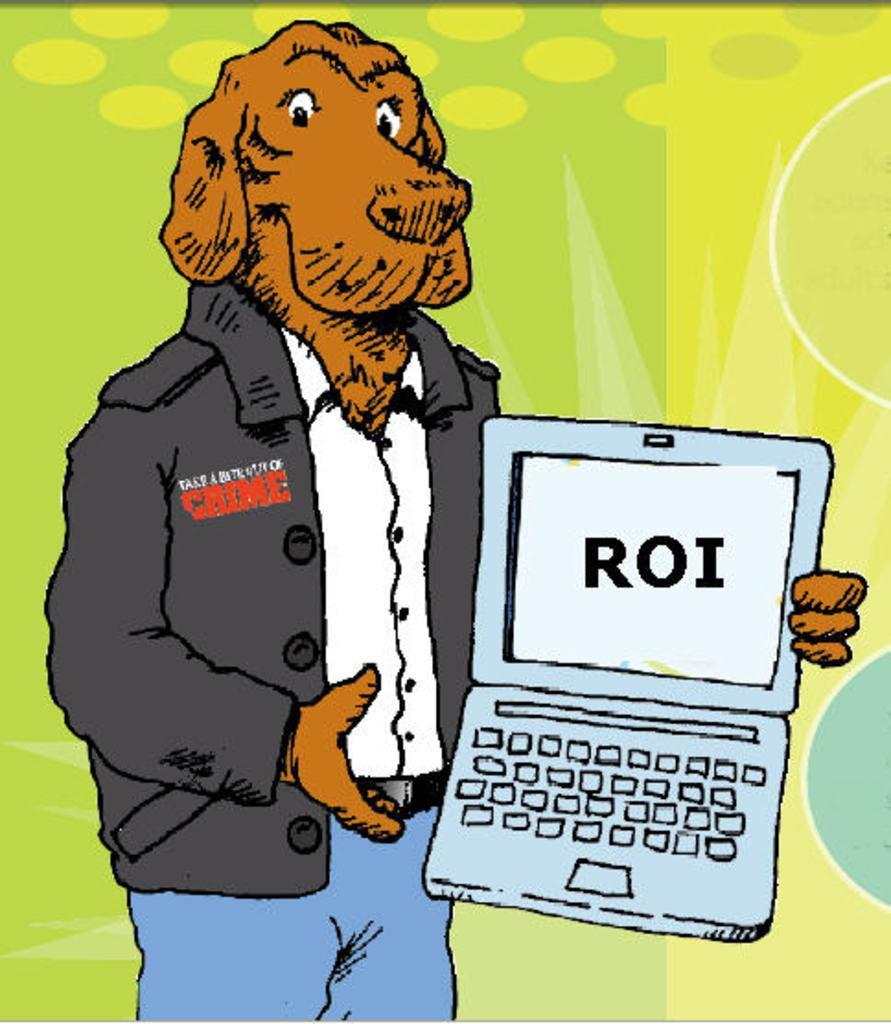In one or two sentences, can you explain what this image depicts? This is a drawing of a dog wearing shirt, coat and jeans and holding a laptop. In the background it is green and yellow color. 